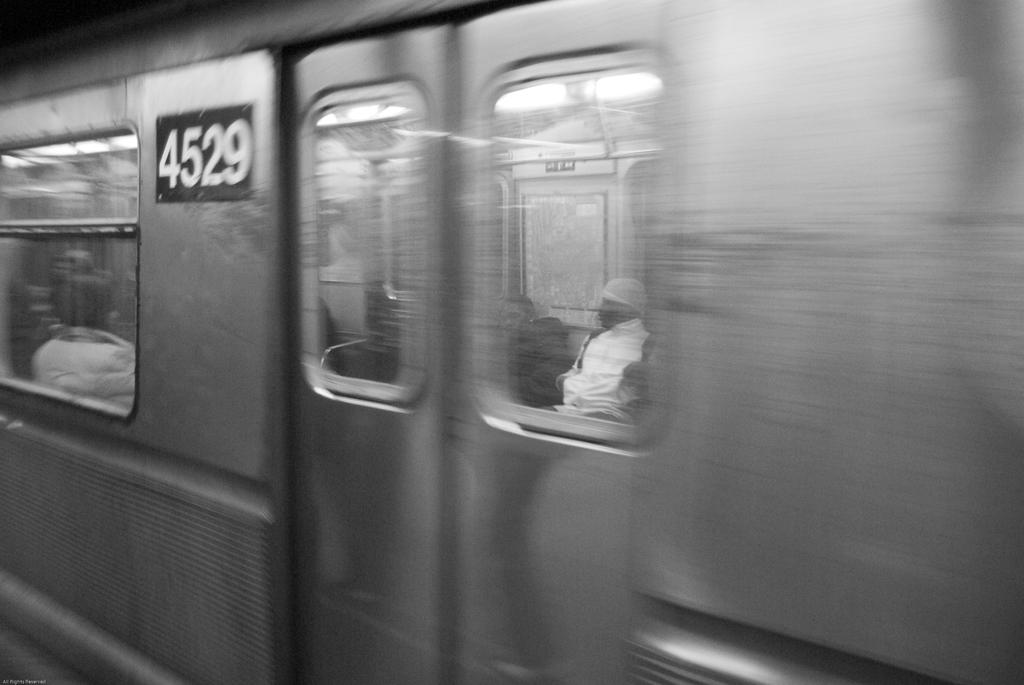<image>
Share a concise interpretation of the image provided. a bus that has the numbers 4529 on it 